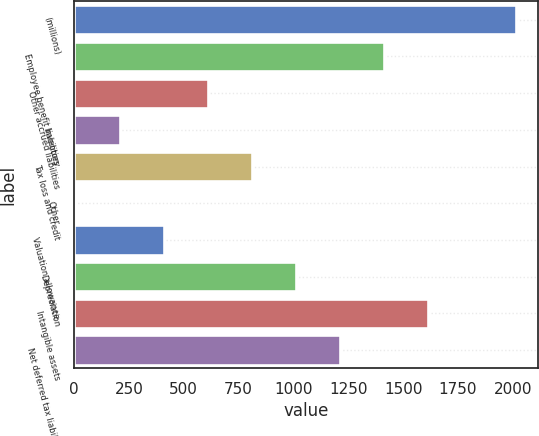Convert chart. <chart><loc_0><loc_0><loc_500><loc_500><bar_chart><fcel>(millions)<fcel>Employee benefit liabilities<fcel>Other accrued liabilities<fcel>Inventory<fcel>Tax loss and credit<fcel>Other<fcel>Valuation allowance<fcel>Depreciation<fcel>Intangible assets<fcel>Net deferred tax liability<nl><fcel>2013<fcel>1411.95<fcel>610.55<fcel>209.85<fcel>810.9<fcel>9.5<fcel>410.2<fcel>1011.25<fcel>1612.3<fcel>1211.6<nl></chart> 